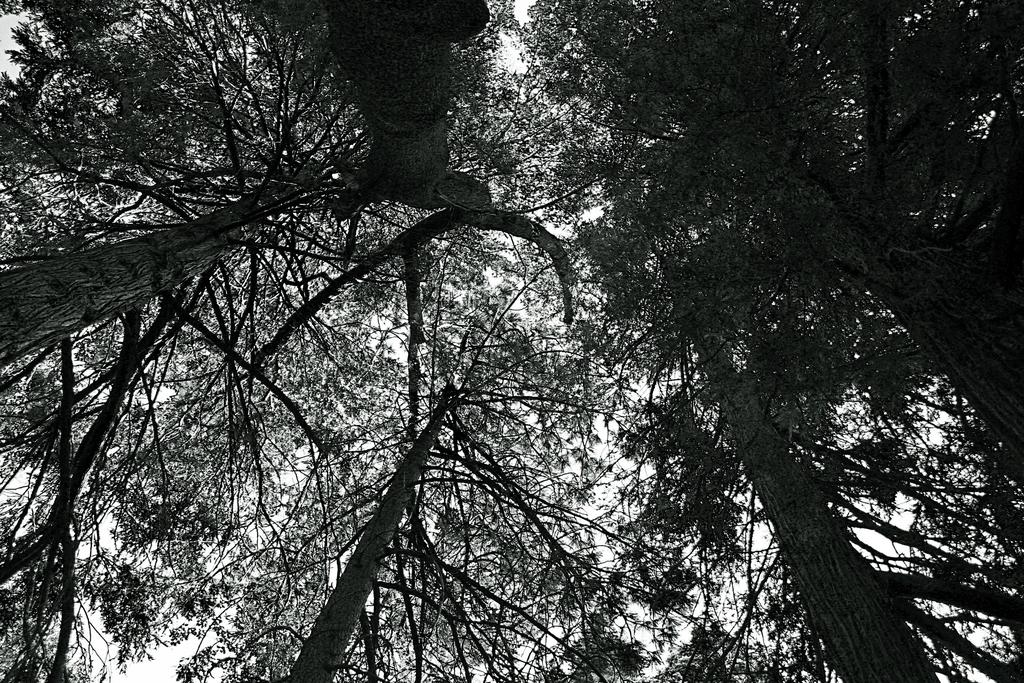What type of vegetation can be seen in the image? There is a group of trees in the image. How many kittens are playing in the scene depicted in the image? There are no kittens present in the image; it only features a group of trees. 